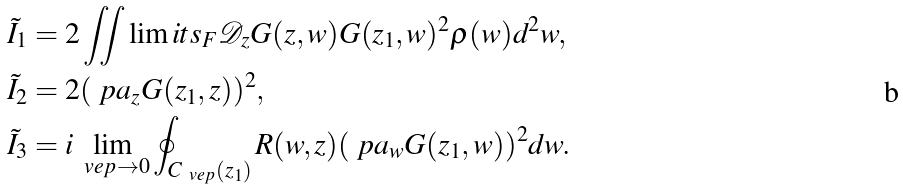<formula> <loc_0><loc_0><loc_500><loc_500>\tilde { I } _ { 1 } & = 2 \iint \lim i t s _ { F } \mathcal { D } _ { z } G ( z , w ) G ( z _ { 1 } , w ) ^ { 2 } \rho ( w ) d ^ { 2 } w , \\ \ \tilde { I } _ { 2 } & = 2 ( \ p a _ { z } G ( z _ { 1 } , z ) ) ^ { 2 } , \\ \tilde { I } _ { 3 } & = i \lim _ { \ v e p \rightarrow 0 } \oint _ { C _ { \ v e p } ( z _ { 1 } ) } R ( w , z ) ( \ p a _ { w } G ( z _ { 1 } , w ) ) ^ { 2 } d w .</formula> 